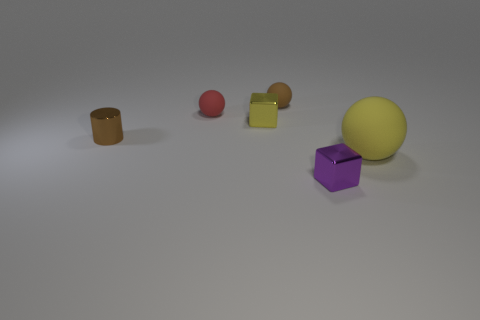Add 1 small blue metal spheres. How many objects exist? 7 Subtract all cylinders. How many objects are left? 5 Add 2 cylinders. How many cylinders exist? 3 Subtract 0 gray spheres. How many objects are left? 6 Subtract all large cyan matte blocks. Subtract all tiny red matte things. How many objects are left? 5 Add 2 red objects. How many red objects are left? 3 